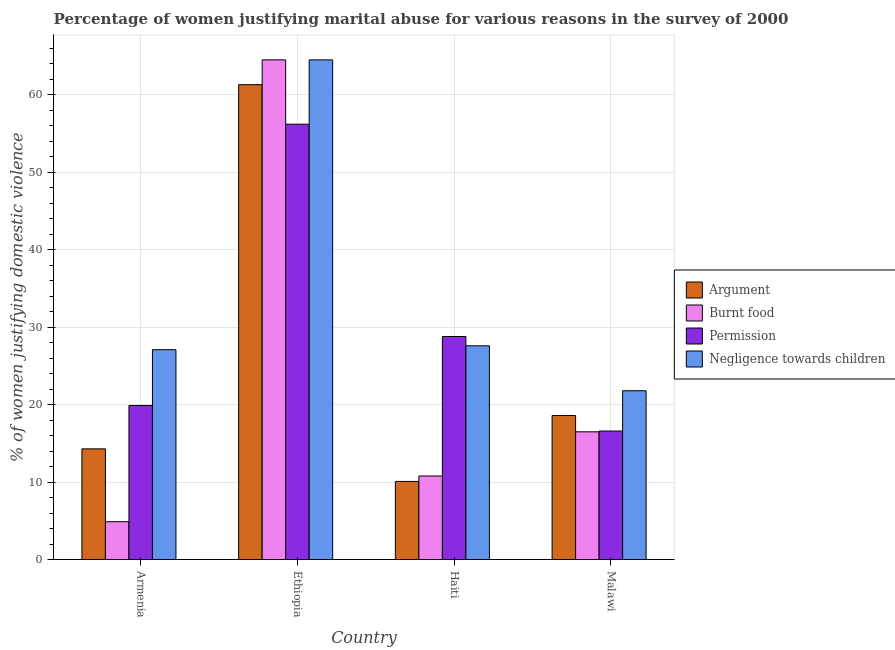How many different coloured bars are there?
Make the answer very short. 4. What is the label of the 3rd group of bars from the left?
Your answer should be compact. Haiti. In how many cases, is the number of bars for a given country not equal to the number of legend labels?
Offer a terse response. 0. What is the percentage of women justifying abuse for burning food in Ethiopia?
Your answer should be compact. 64.5. Across all countries, what is the maximum percentage of women justifying abuse in the case of an argument?
Your response must be concise. 61.3. In which country was the percentage of women justifying abuse in the case of an argument maximum?
Ensure brevity in your answer.  Ethiopia. In which country was the percentage of women justifying abuse for going without permission minimum?
Keep it short and to the point. Malawi. What is the total percentage of women justifying abuse for going without permission in the graph?
Make the answer very short. 121.5. What is the difference between the percentage of women justifying abuse for burning food in Armenia and that in Malawi?
Offer a terse response. -11.6. What is the difference between the percentage of women justifying abuse for going without permission in Haiti and the percentage of women justifying abuse for showing negligence towards children in Armenia?
Offer a terse response. 1.7. What is the average percentage of women justifying abuse for burning food per country?
Offer a very short reply. 24.18. What is the difference between the percentage of women justifying abuse for going without permission and percentage of women justifying abuse in the case of an argument in Ethiopia?
Your response must be concise. -5.1. What is the ratio of the percentage of women justifying abuse for showing negligence towards children in Ethiopia to that in Malawi?
Provide a succinct answer. 2.96. Is the percentage of women justifying abuse for showing negligence towards children in Armenia less than that in Ethiopia?
Keep it short and to the point. Yes. Is the difference between the percentage of women justifying abuse for going without permission in Ethiopia and Malawi greater than the difference between the percentage of women justifying abuse in the case of an argument in Ethiopia and Malawi?
Provide a short and direct response. No. What is the difference between the highest and the second highest percentage of women justifying abuse for showing negligence towards children?
Provide a succinct answer. 36.9. What is the difference between the highest and the lowest percentage of women justifying abuse for showing negligence towards children?
Your answer should be compact. 42.7. What does the 4th bar from the left in Malawi represents?
Provide a succinct answer. Negligence towards children. What does the 3rd bar from the right in Ethiopia represents?
Make the answer very short. Burnt food. Is it the case that in every country, the sum of the percentage of women justifying abuse in the case of an argument and percentage of women justifying abuse for burning food is greater than the percentage of women justifying abuse for going without permission?
Offer a very short reply. No. Are all the bars in the graph horizontal?
Provide a short and direct response. No. How many countries are there in the graph?
Ensure brevity in your answer.  4. What is the difference between two consecutive major ticks on the Y-axis?
Offer a terse response. 10. Are the values on the major ticks of Y-axis written in scientific E-notation?
Provide a succinct answer. No. Does the graph contain any zero values?
Keep it short and to the point. No. How are the legend labels stacked?
Your response must be concise. Vertical. What is the title of the graph?
Keep it short and to the point. Percentage of women justifying marital abuse for various reasons in the survey of 2000. What is the label or title of the X-axis?
Offer a terse response. Country. What is the label or title of the Y-axis?
Provide a short and direct response. % of women justifying domestic violence. What is the % of women justifying domestic violence in Permission in Armenia?
Make the answer very short. 19.9. What is the % of women justifying domestic violence of Negligence towards children in Armenia?
Your answer should be compact. 27.1. What is the % of women justifying domestic violence of Argument in Ethiopia?
Provide a short and direct response. 61.3. What is the % of women justifying domestic violence of Burnt food in Ethiopia?
Ensure brevity in your answer.  64.5. What is the % of women justifying domestic violence of Permission in Ethiopia?
Provide a short and direct response. 56.2. What is the % of women justifying domestic violence in Negligence towards children in Ethiopia?
Offer a terse response. 64.5. What is the % of women justifying domestic violence in Argument in Haiti?
Ensure brevity in your answer.  10.1. What is the % of women justifying domestic violence in Burnt food in Haiti?
Your answer should be compact. 10.8. What is the % of women justifying domestic violence of Permission in Haiti?
Provide a succinct answer. 28.8. What is the % of women justifying domestic violence in Negligence towards children in Haiti?
Give a very brief answer. 27.6. What is the % of women justifying domestic violence of Argument in Malawi?
Your answer should be compact. 18.6. What is the % of women justifying domestic violence of Permission in Malawi?
Offer a very short reply. 16.6. What is the % of women justifying domestic violence of Negligence towards children in Malawi?
Ensure brevity in your answer.  21.8. Across all countries, what is the maximum % of women justifying domestic violence of Argument?
Provide a short and direct response. 61.3. Across all countries, what is the maximum % of women justifying domestic violence of Burnt food?
Keep it short and to the point. 64.5. Across all countries, what is the maximum % of women justifying domestic violence of Permission?
Ensure brevity in your answer.  56.2. Across all countries, what is the maximum % of women justifying domestic violence of Negligence towards children?
Your answer should be very brief. 64.5. Across all countries, what is the minimum % of women justifying domestic violence of Argument?
Keep it short and to the point. 10.1. Across all countries, what is the minimum % of women justifying domestic violence of Negligence towards children?
Your answer should be compact. 21.8. What is the total % of women justifying domestic violence in Argument in the graph?
Your answer should be compact. 104.3. What is the total % of women justifying domestic violence of Burnt food in the graph?
Your response must be concise. 96.7. What is the total % of women justifying domestic violence of Permission in the graph?
Provide a short and direct response. 121.5. What is the total % of women justifying domestic violence in Negligence towards children in the graph?
Offer a very short reply. 141. What is the difference between the % of women justifying domestic violence in Argument in Armenia and that in Ethiopia?
Your answer should be compact. -47. What is the difference between the % of women justifying domestic violence in Burnt food in Armenia and that in Ethiopia?
Your answer should be very brief. -59.6. What is the difference between the % of women justifying domestic violence of Permission in Armenia and that in Ethiopia?
Keep it short and to the point. -36.3. What is the difference between the % of women justifying domestic violence in Negligence towards children in Armenia and that in Ethiopia?
Ensure brevity in your answer.  -37.4. What is the difference between the % of women justifying domestic violence of Argument in Armenia and that in Haiti?
Keep it short and to the point. 4.2. What is the difference between the % of women justifying domestic violence in Burnt food in Armenia and that in Haiti?
Keep it short and to the point. -5.9. What is the difference between the % of women justifying domestic violence of Argument in Armenia and that in Malawi?
Your response must be concise. -4.3. What is the difference between the % of women justifying domestic violence of Burnt food in Armenia and that in Malawi?
Provide a succinct answer. -11.6. What is the difference between the % of women justifying domestic violence in Permission in Armenia and that in Malawi?
Your response must be concise. 3.3. What is the difference between the % of women justifying domestic violence of Argument in Ethiopia and that in Haiti?
Give a very brief answer. 51.2. What is the difference between the % of women justifying domestic violence in Burnt food in Ethiopia and that in Haiti?
Offer a very short reply. 53.7. What is the difference between the % of women justifying domestic violence in Permission in Ethiopia and that in Haiti?
Provide a succinct answer. 27.4. What is the difference between the % of women justifying domestic violence of Negligence towards children in Ethiopia and that in Haiti?
Ensure brevity in your answer.  36.9. What is the difference between the % of women justifying domestic violence in Argument in Ethiopia and that in Malawi?
Ensure brevity in your answer.  42.7. What is the difference between the % of women justifying domestic violence in Permission in Ethiopia and that in Malawi?
Offer a very short reply. 39.6. What is the difference between the % of women justifying domestic violence of Negligence towards children in Ethiopia and that in Malawi?
Offer a terse response. 42.7. What is the difference between the % of women justifying domestic violence in Argument in Haiti and that in Malawi?
Your answer should be very brief. -8.5. What is the difference between the % of women justifying domestic violence in Burnt food in Haiti and that in Malawi?
Your response must be concise. -5.7. What is the difference between the % of women justifying domestic violence in Permission in Haiti and that in Malawi?
Offer a very short reply. 12.2. What is the difference between the % of women justifying domestic violence in Negligence towards children in Haiti and that in Malawi?
Keep it short and to the point. 5.8. What is the difference between the % of women justifying domestic violence in Argument in Armenia and the % of women justifying domestic violence in Burnt food in Ethiopia?
Give a very brief answer. -50.2. What is the difference between the % of women justifying domestic violence of Argument in Armenia and the % of women justifying domestic violence of Permission in Ethiopia?
Provide a succinct answer. -41.9. What is the difference between the % of women justifying domestic violence of Argument in Armenia and the % of women justifying domestic violence of Negligence towards children in Ethiopia?
Ensure brevity in your answer.  -50.2. What is the difference between the % of women justifying domestic violence in Burnt food in Armenia and the % of women justifying domestic violence in Permission in Ethiopia?
Your answer should be very brief. -51.3. What is the difference between the % of women justifying domestic violence in Burnt food in Armenia and the % of women justifying domestic violence in Negligence towards children in Ethiopia?
Give a very brief answer. -59.6. What is the difference between the % of women justifying domestic violence in Permission in Armenia and the % of women justifying domestic violence in Negligence towards children in Ethiopia?
Your answer should be very brief. -44.6. What is the difference between the % of women justifying domestic violence in Argument in Armenia and the % of women justifying domestic violence in Permission in Haiti?
Offer a very short reply. -14.5. What is the difference between the % of women justifying domestic violence in Burnt food in Armenia and the % of women justifying domestic violence in Permission in Haiti?
Give a very brief answer. -23.9. What is the difference between the % of women justifying domestic violence of Burnt food in Armenia and the % of women justifying domestic violence of Negligence towards children in Haiti?
Offer a terse response. -22.7. What is the difference between the % of women justifying domestic violence of Permission in Armenia and the % of women justifying domestic violence of Negligence towards children in Haiti?
Make the answer very short. -7.7. What is the difference between the % of women justifying domestic violence of Argument in Armenia and the % of women justifying domestic violence of Permission in Malawi?
Your answer should be compact. -2.3. What is the difference between the % of women justifying domestic violence in Burnt food in Armenia and the % of women justifying domestic violence in Negligence towards children in Malawi?
Give a very brief answer. -16.9. What is the difference between the % of women justifying domestic violence of Permission in Armenia and the % of women justifying domestic violence of Negligence towards children in Malawi?
Ensure brevity in your answer.  -1.9. What is the difference between the % of women justifying domestic violence in Argument in Ethiopia and the % of women justifying domestic violence in Burnt food in Haiti?
Make the answer very short. 50.5. What is the difference between the % of women justifying domestic violence of Argument in Ethiopia and the % of women justifying domestic violence of Permission in Haiti?
Your answer should be compact. 32.5. What is the difference between the % of women justifying domestic violence of Argument in Ethiopia and the % of women justifying domestic violence of Negligence towards children in Haiti?
Give a very brief answer. 33.7. What is the difference between the % of women justifying domestic violence of Burnt food in Ethiopia and the % of women justifying domestic violence of Permission in Haiti?
Keep it short and to the point. 35.7. What is the difference between the % of women justifying domestic violence in Burnt food in Ethiopia and the % of women justifying domestic violence in Negligence towards children in Haiti?
Make the answer very short. 36.9. What is the difference between the % of women justifying domestic violence in Permission in Ethiopia and the % of women justifying domestic violence in Negligence towards children in Haiti?
Provide a short and direct response. 28.6. What is the difference between the % of women justifying domestic violence of Argument in Ethiopia and the % of women justifying domestic violence of Burnt food in Malawi?
Offer a terse response. 44.8. What is the difference between the % of women justifying domestic violence of Argument in Ethiopia and the % of women justifying domestic violence of Permission in Malawi?
Your answer should be compact. 44.7. What is the difference between the % of women justifying domestic violence of Argument in Ethiopia and the % of women justifying domestic violence of Negligence towards children in Malawi?
Provide a short and direct response. 39.5. What is the difference between the % of women justifying domestic violence of Burnt food in Ethiopia and the % of women justifying domestic violence of Permission in Malawi?
Give a very brief answer. 47.9. What is the difference between the % of women justifying domestic violence of Burnt food in Ethiopia and the % of women justifying domestic violence of Negligence towards children in Malawi?
Offer a terse response. 42.7. What is the difference between the % of women justifying domestic violence in Permission in Ethiopia and the % of women justifying domestic violence in Negligence towards children in Malawi?
Make the answer very short. 34.4. What is the difference between the % of women justifying domestic violence of Argument in Haiti and the % of women justifying domestic violence of Negligence towards children in Malawi?
Offer a very short reply. -11.7. What is the average % of women justifying domestic violence of Argument per country?
Your answer should be compact. 26.07. What is the average % of women justifying domestic violence of Burnt food per country?
Make the answer very short. 24.18. What is the average % of women justifying domestic violence of Permission per country?
Make the answer very short. 30.38. What is the average % of women justifying domestic violence in Negligence towards children per country?
Your response must be concise. 35.25. What is the difference between the % of women justifying domestic violence in Argument and % of women justifying domestic violence in Burnt food in Armenia?
Your answer should be very brief. 9.4. What is the difference between the % of women justifying domestic violence in Argument and % of women justifying domestic violence in Negligence towards children in Armenia?
Your answer should be very brief. -12.8. What is the difference between the % of women justifying domestic violence of Burnt food and % of women justifying domestic violence of Negligence towards children in Armenia?
Make the answer very short. -22.2. What is the difference between the % of women justifying domestic violence of Argument and % of women justifying domestic violence of Negligence towards children in Ethiopia?
Your response must be concise. -3.2. What is the difference between the % of women justifying domestic violence of Burnt food and % of women justifying domestic violence of Permission in Ethiopia?
Ensure brevity in your answer.  8.3. What is the difference between the % of women justifying domestic violence of Argument and % of women justifying domestic violence of Permission in Haiti?
Provide a succinct answer. -18.7. What is the difference between the % of women justifying domestic violence in Argument and % of women justifying domestic violence in Negligence towards children in Haiti?
Make the answer very short. -17.5. What is the difference between the % of women justifying domestic violence of Burnt food and % of women justifying domestic violence of Negligence towards children in Haiti?
Your response must be concise. -16.8. What is the difference between the % of women justifying domestic violence in Permission and % of women justifying domestic violence in Negligence towards children in Haiti?
Provide a short and direct response. 1.2. What is the difference between the % of women justifying domestic violence of Argument and % of women justifying domestic violence of Negligence towards children in Malawi?
Offer a terse response. -3.2. What is the difference between the % of women justifying domestic violence of Burnt food and % of women justifying domestic violence of Permission in Malawi?
Offer a terse response. -0.1. What is the difference between the % of women justifying domestic violence in Permission and % of women justifying domestic violence in Negligence towards children in Malawi?
Offer a terse response. -5.2. What is the ratio of the % of women justifying domestic violence in Argument in Armenia to that in Ethiopia?
Provide a succinct answer. 0.23. What is the ratio of the % of women justifying domestic violence of Burnt food in Armenia to that in Ethiopia?
Provide a short and direct response. 0.08. What is the ratio of the % of women justifying domestic violence in Permission in Armenia to that in Ethiopia?
Your response must be concise. 0.35. What is the ratio of the % of women justifying domestic violence of Negligence towards children in Armenia to that in Ethiopia?
Keep it short and to the point. 0.42. What is the ratio of the % of women justifying domestic violence in Argument in Armenia to that in Haiti?
Offer a very short reply. 1.42. What is the ratio of the % of women justifying domestic violence in Burnt food in Armenia to that in Haiti?
Your answer should be compact. 0.45. What is the ratio of the % of women justifying domestic violence in Permission in Armenia to that in Haiti?
Keep it short and to the point. 0.69. What is the ratio of the % of women justifying domestic violence in Negligence towards children in Armenia to that in Haiti?
Keep it short and to the point. 0.98. What is the ratio of the % of women justifying domestic violence of Argument in Armenia to that in Malawi?
Your answer should be compact. 0.77. What is the ratio of the % of women justifying domestic violence of Burnt food in Armenia to that in Malawi?
Make the answer very short. 0.3. What is the ratio of the % of women justifying domestic violence in Permission in Armenia to that in Malawi?
Give a very brief answer. 1.2. What is the ratio of the % of women justifying domestic violence of Negligence towards children in Armenia to that in Malawi?
Your answer should be compact. 1.24. What is the ratio of the % of women justifying domestic violence of Argument in Ethiopia to that in Haiti?
Give a very brief answer. 6.07. What is the ratio of the % of women justifying domestic violence in Burnt food in Ethiopia to that in Haiti?
Your answer should be very brief. 5.97. What is the ratio of the % of women justifying domestic violence in Permission in Ethiopia to that in Haiti?
Give a very brief answer. 1.95. What is the ratio of the % of women justifying domestic violence of Negligence towards children in Ethiopia to that in Haiti?
Your answer should be compact. 2.34. What is the ratio of the % of women justifying domestic violence of Argument in Ethiopia to that in Malawi?
Your answer should be compact. 3.3. What is the ratio of the % of women justifying domestic violence of Burnt food in Ethiopia to that in Malawi?
Your response must be concise. 3.91. What is the ratio of the % of women justifying domestic violence of Permission in Ethiopia to that in Malawi?
Provide a short and direct response. 3.39. What is the ratio of the % of women justifying domestic violence in Negligence towards children in Ethiopia to that in Malawi?
Your response must be concise. 2.96. What is the ratio of the % of women justifying domestic violence in Argument in Haiti to that in Malawi?
Your answer should be compact. 0.54. What is the ratio of the % of women justifying domestic violence in Burnt food in Haiti to that in Malawi?
Offer a terse response. 0.65. What is the ratio of the % of women justifying domestic violence of Permission in Haiti to that in Malawi?
Ensure brevity in your answer.  1.73. What is the ratio of the % of women justifying domestic violence in Negligence towards children in Haiti to that in Malawi?
Your answer should be compact. 1.27. What is the difference between the highest and the second highest % of women justifying domestic violence in Argument?
Give a very brief answer. 42.7. What is the difference between the highest and the second highest % of women justifying domestic violence in Permission?
Offer a very short reply. 27.4. What is the difference between the highest and the second highest % of women justifying domestic violence of Negligence towards children?
Give a very brief answer. 36.9. What is the difference between the highest and the lowest % of women justifying domestic violence in Argument?
Provide a succinct answer. 51.2. What is the difference between the highest and the lowest % of women justifying domestic violence in Burnt food?
Make the answer very short. 59.6. What is the difference between the highest and the lowest % of women justifying domestic violence of Permission?
Ensure brevity in your answer.  39.6. What is the difference between the highest and the lowest % of women justifying domestic violence of Negligence towards children?
Offer a terse response. 42.7. 